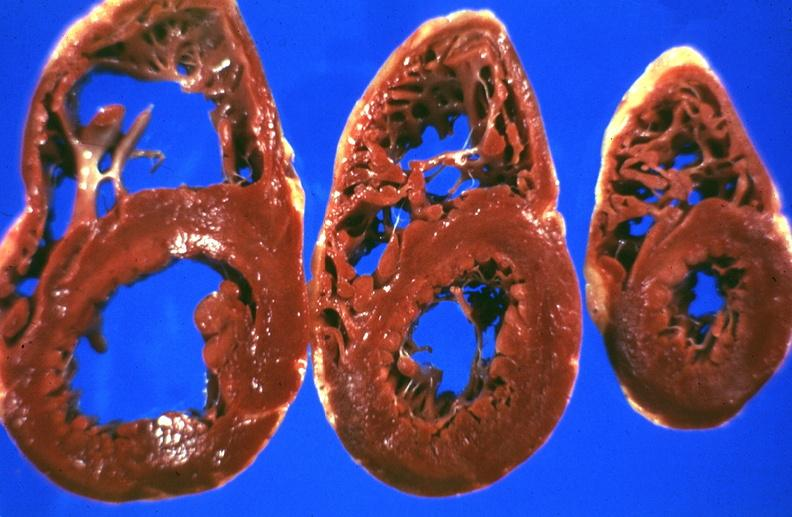does this image show liver, hemochromatosis?
Answer the question using a single word or phrase. Yes 